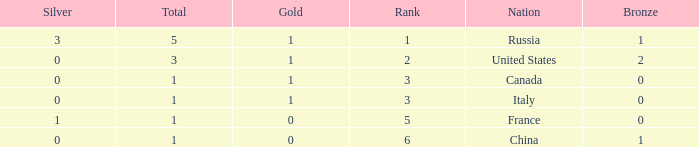Name the total number of ranks when total is less than 1 0.0. 